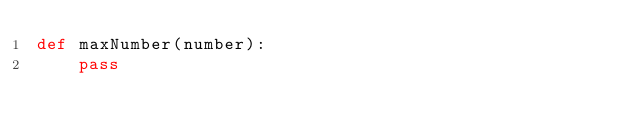Convert code to text. <code><loc_0><loc_0><loc_500><loc_500><_Python_>def maxNumber(number):
    pass
</code> 